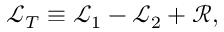Convert formula to latex. <formula><loc_0><loc_0><loc_500><loc_500>\mathcal { L } _ { T } \equiv \mathcal { L } _ { 1 } - \mathcal { L } _ { 2 } + \mathcal { R } ,</formula> 